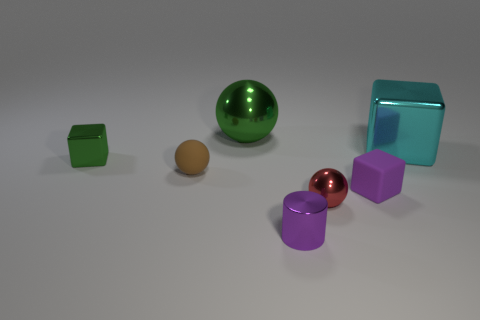Subtract all metal balls. How many balls are left? 1 Add 1 big blue metallic cylinders. How many objects exist? 8 Subtract 1 blocks. How many blocks are left? 2 Subtract all cubes. How many objects are left? 4 Subtract all blue spheres. Subtract all red cubes. How many spheres are left? 3 Subtract all small rubber objects. Subtract all tiny brown rubber cubes. How many objects are left? 5 Add 2 cylinders. How many cylinders are left? 3 Add 4 small red blocks. How many small red blocks exist? 4 Subtract 0 gray blocks. How many objects are left? 7 